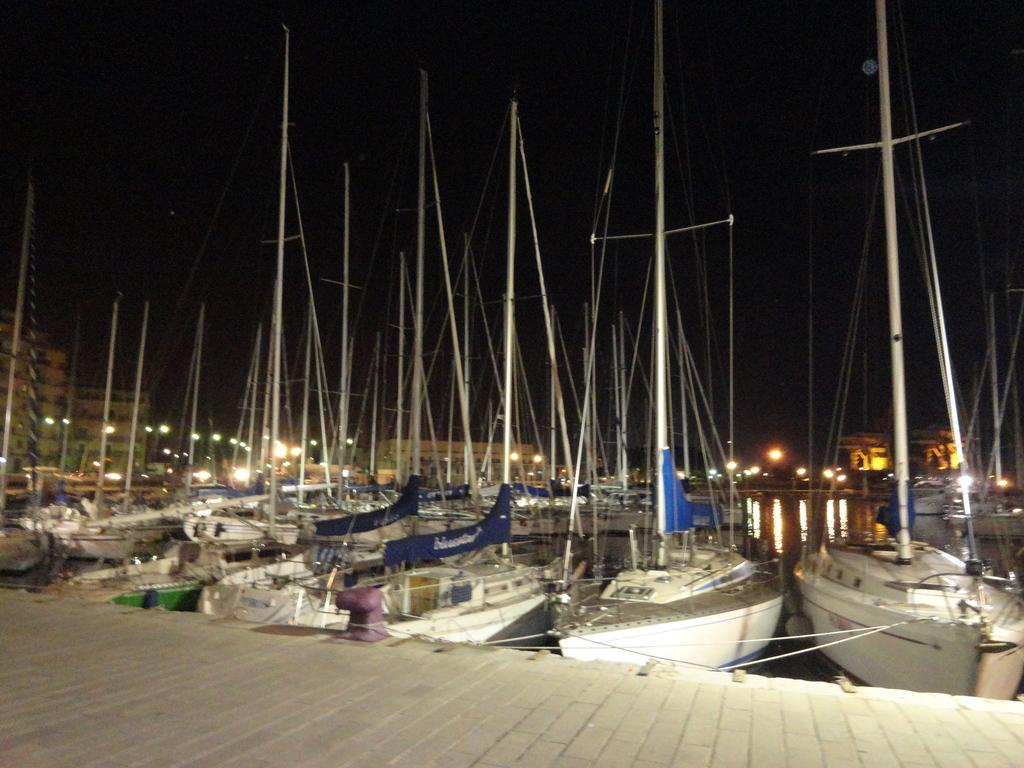What type of flooring is at the bottom of the image? There is wooden flooring at the bottom of the image. What can be seen in the background of the image? There are ships, water, buildings, and the sky visible in the background of the image. What type of bag is being used to collect income from the ships in the image? There is no bag or mention of income in the image; it features a wooden floor and a background with ships, water, buildings, and the sky. 